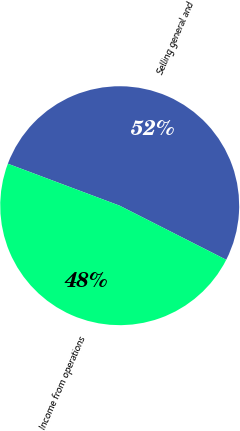Convert chart to OTSL. <chart><loc_0><loc_0><loc_500><loc_500><pie_chart><fcel>Selling general and<fcel>Income from operations<nl><fcel>51.76%<fcel>48.24%<nl></chart> 